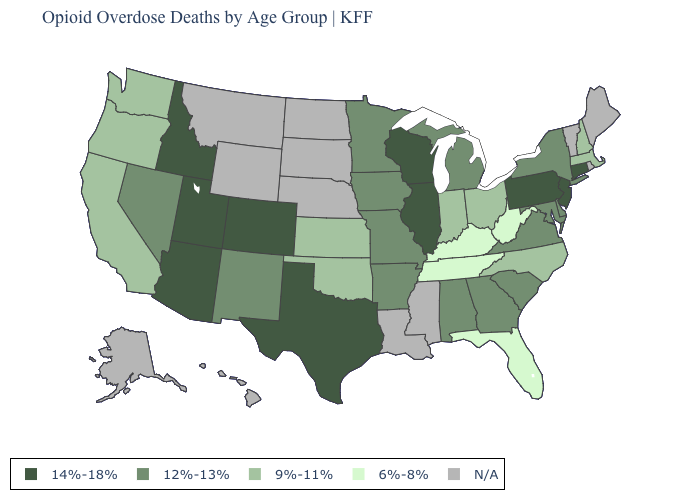Among the states that border Texas , which have the lowest value?
Concise answer only. Oklahoma. Name the states that have a value in the range 9%-11%?
Short answer required. California, Indiana, Kansas, Massachusetts, New Hampshire, North Carolina, Ohio, Oklahoma, Oregon, Washington. What is the value of Florida?
Give a very brief answer. 6%-8%. What is the value of Oregon?
Short answer required. 9%-11%. Does the first symbol in the legend represent the smallest category?
Keep it brief. No. What is the value of Washington?
Be succinct. 9%-11%. Name the states that have a value in the range 14%-18%?
Quick response, please. Arizona, Colorado, Connecticut, Idaho, Illinois, New Jersey, Pennsylvania, Texas, Utah, Wisconsin. What is the value of Florida?
Give a very brief answer. 6%-8%. What is the highest value in the Northeast ?
Answer briefly. 14%-18%. Name the states that have a value in the range 6%-8%?
Short answer required. Florida, Kentucky, Tennessee, West Virginia. What is the lowest value in the MidWest?
Short answer required. 9%-11%. Which states have the lowest value in the USA?
Answer briefly. Florida, Kentucky, Tennessee, West Virginia. What is the value of Nebraska?
Concise answer only. N/A. 